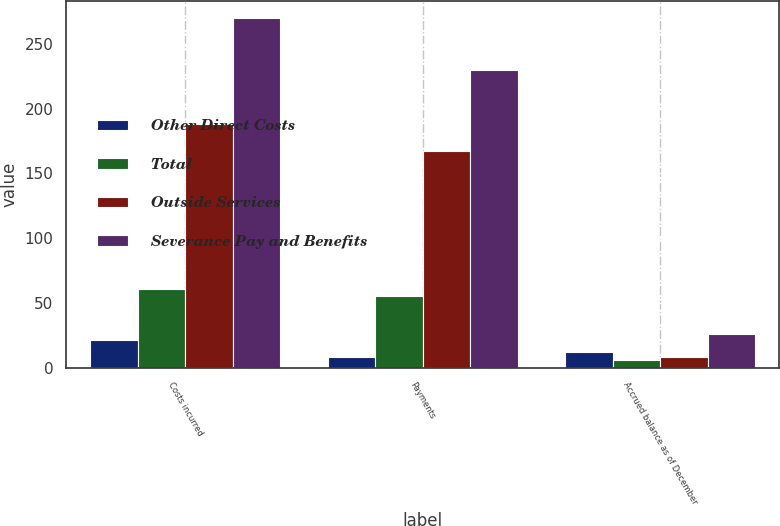<chart> <loc_0><loc_0><loc_500><loc_500><stacked_bar_chart><ecel><fcel>Costs incurred<fcel>Payments<fcel>Accrued balance as of December<nl><fcel>Other Direct Costs<fcel>21<fcel>8<fcel>12<nl><fcel>Total<fcel>61<fcel>55<fcel>6<nl><fcel>Outside Services<fcel>188<fcel>167<fcel>8<nl><fcel>Severance Pay and Benefits<fcel>270<fcel>230<fcel>26<nl></chart> 